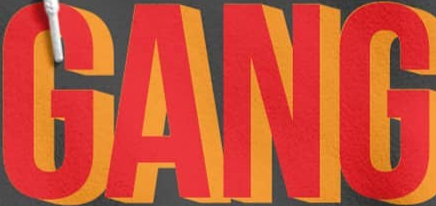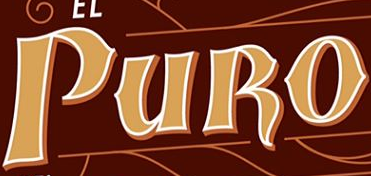What words can you see in these images in sequence, separated by a semicolon? GANG; PURO 